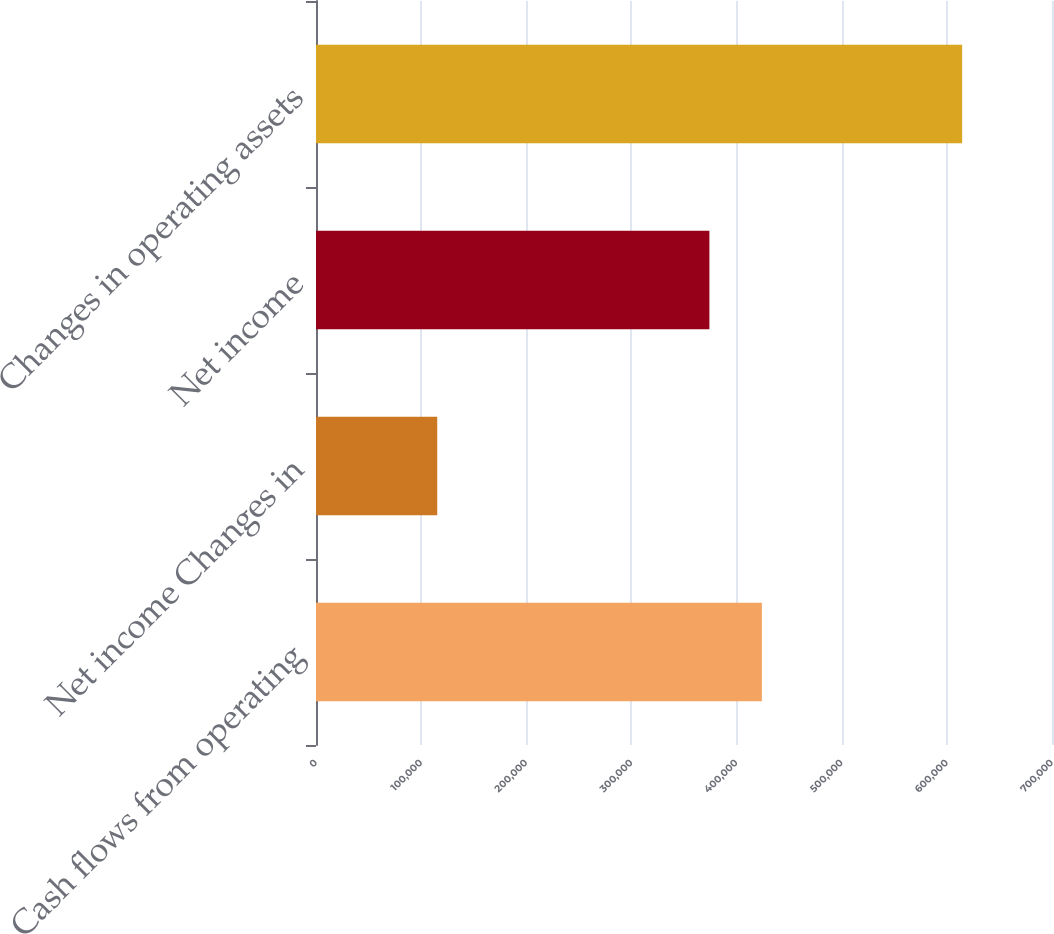<chart> <loc_0><loc_0><loc_500><loc_500><bar_chart><fcel>Cash flows from operating<fcel>Net income Changes in<fcel>Net income<fcel>Changes in operating assets<nl><fcel>424084<fcel>115305<fcel>374160<fcel>614540<nl></chart> 